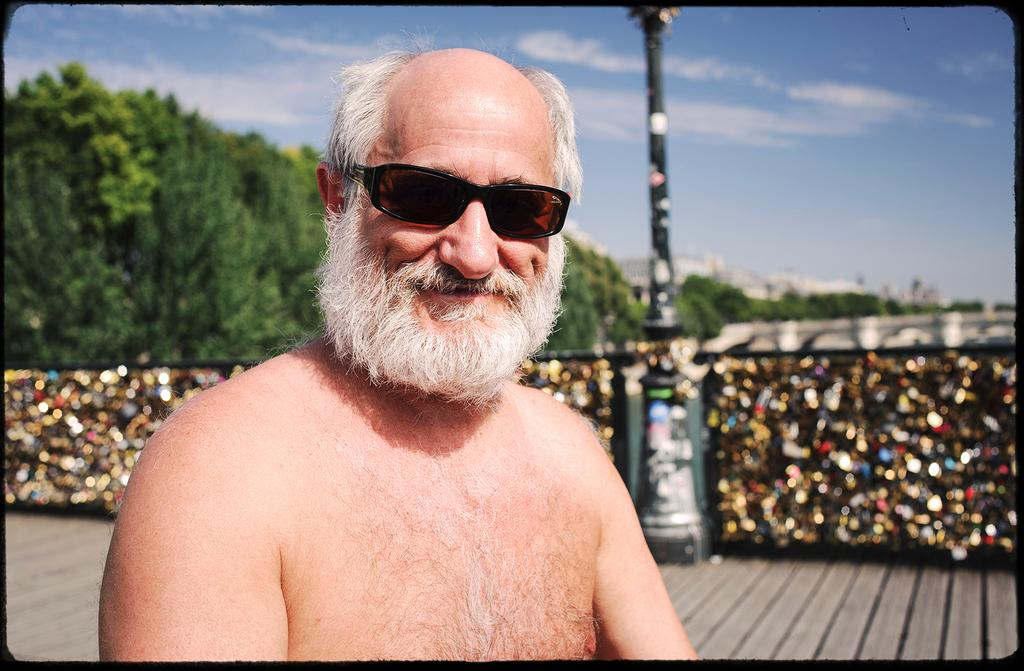What is the person in the image wearing? The person in the image is wearing glasses. What can be seen in the background of the image? There are trees, a pole, buildings, and the sky visible in the background of the image. What is the condition of the sky in the image? The sky is visible in the background of the image, and there are clouds present. What type of chin can be seen on the person in the image? There is no chin visible in the image; only the person's glasses are mentioned. How is the distribution of trees and buildings in the background of the image? The distribution of trees and buildings in the background of the image cannot be determined from the image itself, as it only provides a snapshot of the scene. 